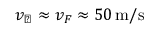Convert formula to latex. <formula><loc_0><loc_0><loc_500><loc_500>v _ { \perp } \approx v _ { F } \approx 5 0 \, m / s</formula> 